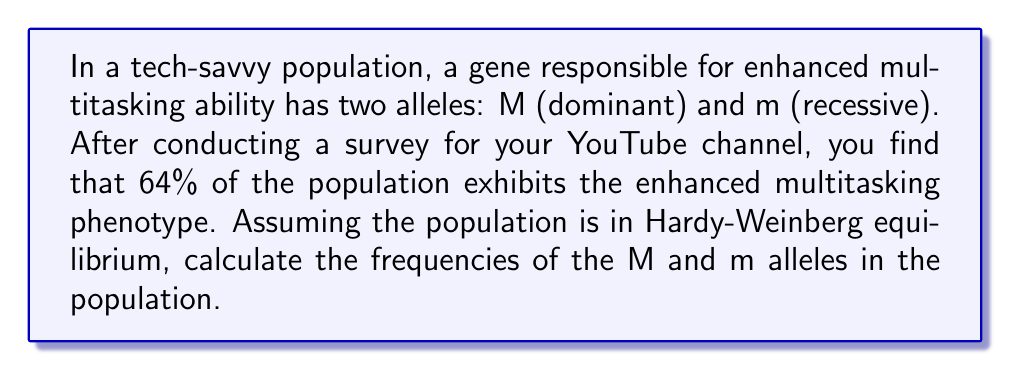Teach me how to tackle this problem. To solve this problem using the Hardy-Weinberg principle, let's follow these steps:

1. Define variables:
   Let p = frequency of the dominant allele (M)
   Let q = frequency of the recessive allele (m)

2. Hardy-Weinberg principle states:
   $p + q = 1$
   $p^2 + 2pq + q^2 = 1$

3. Given information:
   64% of the population exhibits the enhanced multitasking phenotype.
   This means 36% of the population is homozygous recessive (mm).

4. Calculate q:
   $q^2 = 0.36$
   $q = \sqrt{0.36} = 0.6$

5. Calculate p:
   $p + q = 1$
   $p = 1 - q = 1 - 0.6 = 0.4$

6. Verify the result:
   $p^2 + 2pq + q^2 = (0.4)^2 + 2(0.4)(0.6) + (0.6)^2$
   $= 0.16 + 0.48 + 0.36 = 1$

Therefore, the frequency of the M allele (p) is 0.4 or 40%, and the frequency of the m allele (q) is 0.6 or 60%.
Answer: The frequency of the M allele is 0.4 (40%), and the frequency of the m allele is 0.6 (60%). 